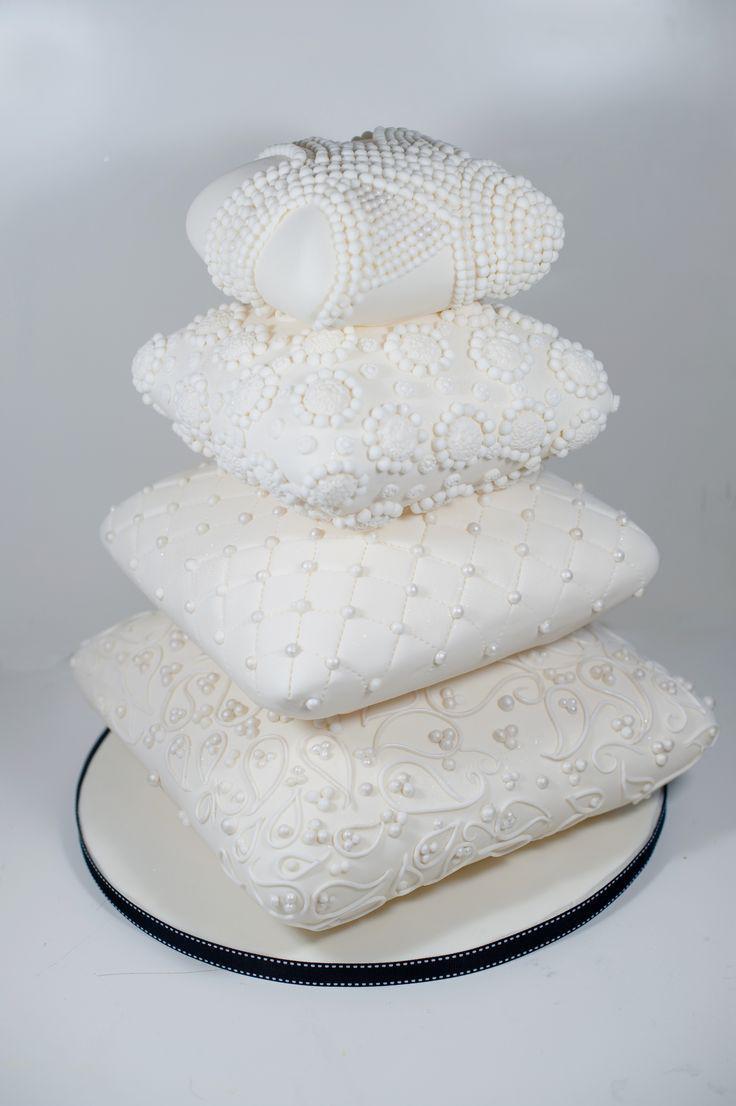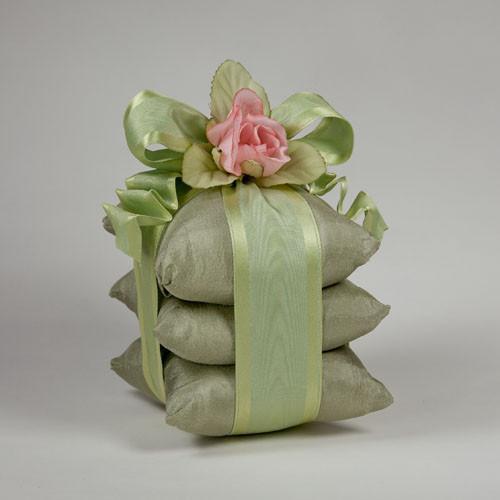The first image is the image on the left, the second image is the image on the right. Considering the images on both sides, is "One of the stacks has exactly three pillows and is decorated with ribbons and flowers." valid? Answer yes or no. Yes. 